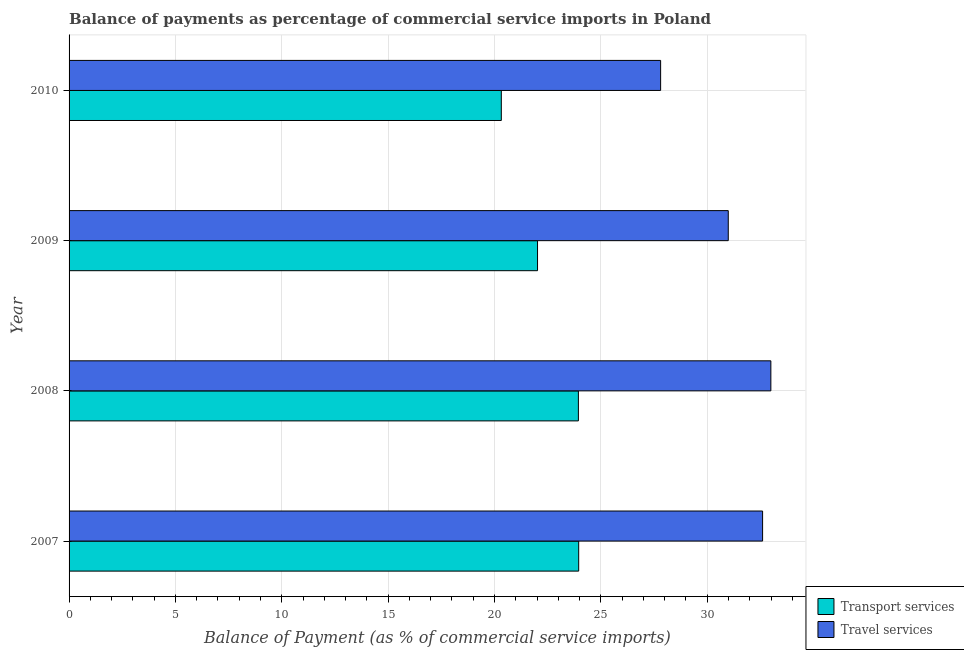How many groups of bars are there?
Your answer should be very brief. 4. Are the number of bars per tick equal to the number of legend labels?
Give a very brief answer. Yes. How many bars are there on the 4th tick from the bottom?
Your answer should be very brief. 2. In how many cases, is the number of bars for a given year not equal to the number of legend labels?
Provide a succinct answer. 0. What is the balance of payments of travel services in 2008?
Provide a succinct answer. 32.99. Across all years, what is the maximum balance of payments of transport services?
Offer a terse response. 23.96. Across all years, what is the minimum balance of payments of transport services?
Your response must be concise. 20.32. In which year was the balance of payments of travel services maximum?
Provide a short and direct response. 2008. What is the total balance of payments of transport services in the graph?
Your response must be concise. 90.24. What is the difference between the balance of payments of travel services in 2009 and that in 2010?
Offer a very short reply. 3.18. What is the difference between the balance of payments of transport services in 2009 and the balance of payments of travel services in 2007?
Ensure brevity in your answer.  -10.58. What is the average balance of payments of transport services per year?
Offer a very short reply. 22.56. In the year 2010, what is the difference between the balance of payments of travel services and balance of payments of transport services?
Your answer should be compact. 7.49. What is the ratio of the balance of payments of travel services in 2008 to that in 2009?
Your answer should be compact. 1.06. Is the difference between the balance of payments of transport services in 2007 and 2008 greater than the difference between the balance of payments of travel services in 2007 and 2008?
Your response must be concise. Yes. What is the difference between the highest and the second highest balance of payments of travel services?
Offer a very short reply. 0.39. What is the difference between the highest and the lowest balance of payments of travel services?
Your answer should be compact. 5.18. Is the sum of the balance of payments of travel services in 2008 and 2010 greater than the maximum balance of payments of transport services across all years?
Your answer should be very brief. Yes. What does the 1st bar from the top in 2008 represents?
Make the answer very short. Travel services. What does the 2nd bar from the bottom in 2009 represents?
Your answer should be very brief. Travel services. Does the graph contain grids?
Make the answer very short. Yes. Where does the legend appear in the graph?
Offer a very short reply. Bottom right. How are the legend labels stacked?
Your answer should be very brief. Vertical. What is the title of the graph?
Provide a succinct answer. Balance of payments as percentage of commercial service imports in Poland. What is the label or title of the X-axis?
Provide a succinct answer. Balance of Payment (as % of commercial service imports). What is the label or title of the Y-axis?
Provide a short and direct response. Year. What is the Balance of Payment (as % of commercial service imports) in Transport services in 2007?
Provide a short and direct response. 23.96. What is the Balance of Payment (as % of commercial service imports) in Travel services in 2007?
Offer a very short reply. 32.6. What is the Balance of Payment (as % of commercial service imports) of Transport services in 2008?
Your answer should be compact. 23.94. What is the Balance of Payment (as % of commercial service imports) of Travel services in 2008?
Keep it short and to the point. 32.99. What is the Balance of Payment (as % of commercial service imports) in Transport services in 2009?
Offer a terse response. 22.02. What is the Balance of Payment (as % of commercial service imports) of Travel services in 2009?
Give a very brief answer. 30.99. What is the Balance of Payment (as % of commercial service imports) of Transport services in 2010?
Your response must be concise. 20.32. What is the Balance of Payment (as % of commercial service imports) in Travel services in 2010?
Offer a terse response. 27.81. Across all years, what is the maximum Balance of Payment (as % of commercial service imports) in Transport services?
Give a very brief answer. 23.96. Across all years, what is the maximum Balance of Payment (as % of commercial service imports) in Travel services?
Provide a short and direct response. 32.99. Across all years, what is the minimum Balance of Payment (as % of commercial service imports) in Transport services?
Provide a succinct answer. 20.32. Across all years, what is the minimum Balance of Payment (as % of commercial service imports) of Travel services?
Your answer should be compact. 27.81. What is the total Balance of Payment (as % of commercial service imports) in Transport services in the graph?
Offer a terse response. 90.24. What is the total Balance of Payment (as % of commercial service imports) of Travel services in the graph?
Make the answer very short. 124.39. What is the difference between the Balance of Payment (as % of commercial service imports) in Transport services in 2007 and that in 2008?
Your answer should be very brief. 0.01. What is the difference between the Balance of Payment (as % of commercial service imports) of Travel services in 2007 and that in 2008?
Your answer should be very brief. -0.39. What is the difference between the Balance of Payment (as % of commercial service imports) of Transport services in 2007 and that in 2009?
Ensure brevity in your answer.  1.93. What is the difference between the Balance of Payment (as % of commercial service imports) in Travel services in 2007 and that in 2009?
Keep it short and to the point. 1.61. What is the difference between the Balance of Payment (as % of commercial service imports) of Transport services in 2007 and that in 2010?
Ensure brevity in your answer.  3.64. What is the difference between the Balance of Payment (as % of commercial service imports) of Travel services in 2007 and that in 2010?
Your answer should be very brief. 4.79. What is the difference between the Balance of Payment (as % of commercial service imports) in Transport services in 2008 and that in 2009?
Give a very brief answer. 1.92. What is the difference between the Balance of Payment (as % of commercial service imports) in Travel services in 2008 and that in 2009?
Offer a terse response. 2. What is the difference between the Balance of Payment (as % of commercial service imports) of Transport services in 2008 and that in 2010?
Your answer should be compact. 3.62. What is the difference between the Balance of Payment (as % of commercial service imports) in Travel services in 2008 and that in 2010?
Your response must be concise. 5.18. What is the difference between the Balance of Payment (as % of commercial service imports) of Transport services in 2009 and that in 2010?
Offer a terse response. 1.7. What is the difference between the Balance of Payment (as % of commercial service imports) in Travel services in 2009 and that in 2010?
Give a very brief answer. 3.18. What is the difference between the Balance of Payment (as % of commercial service imports) in Transport services in 2007 and the Balance of Payment (as % of commercial service imports) in Travel services in 2008?
Offer a terse response. -9.03. What is the difference between the Balance of Payment (as % of commercial service imports) of Transport services in 2007 and the Balance of Payment (as % of commercial service imports) of Travel services in 2009?
Offer a very short reply. -7.03. What is the difference between the Balance of Payment (as % of commercial service imports) of Transport services in 2007 and the Balance of Payment (as % of commercial service imports) of Travel services in 2010?
Give a very brief answer. -3.85. What is the difference between the Balance of Payment (as % of commercial service imports) of Transport services in 2008 and the Balance of Payment (as % of commercial service imports) of Travel services in 2009?
Offer a very short reply. -7.05. What is the difference between the Balance of Payment (as % of commercial service imports) in Transport services in 2008 and the Balance of Payment (as % of commercial service imports) in Travel services in 2010?
Keep it short and to the point. -3.87. What is the difference between the Balance of Payment (as % of commercial service imports) of Transport services in 2009 and the Balance of Payment (as % of commercial service imports) of Travel services in 2010?
Offer a very short reply. -5.79. What is the average Balance of Payment (as % of commercial service imports) in Transport services per year?
Make the answer very short. 22.56. What is the average Balance of Payment (as % of commercial service imports) of Travel services per year?
Provide a succinct answer. 31.1. In the year 2007, what is the difference between the Balance of Payment (as % of commercial service imports) of Transport services and Balance of Payment (as % of commercial service imports) of Travel services?
Provide a succinct answer. -8.65. In the year 2008, what is the difference between the Balance of Payment (as % of commercial service imports) of Transport services and Balance of Payment (as % of commercial service imports) of Travel services?
Give a very brief answer. -9.05. In the year 2009, what is the difference between the Balance of Payment (as % of commercial service imports) in Transport services and Balance of Payment (as % of commercial service imports) in Travel services?
Your response must be concise. -8.97. In the year 2010, what is the difference between the Balance of Payment (as % of commercial service imports) of Transport services and Balance of Payment (as % of commercial service imports) of Travel services?
Your answer should be compact. -7.49. What is the ratio of the Balance of Payment (as % of commercial service imports) of Transport services in 2007 to that in 2009?
Keep it short and to the point. 1.09. What is the ratio of the Balance of Payment (as % of commercial service imports) of Travel services in 2007 to that in 2009?
Ensure brevity in your answer.  1.05. What is the ratio of the Balance of Payment (as % of commercial service imports) in Transport services in 2007 to that in 2010?
Your response must be concise. 1.18. What is the ratio of the Balance of Payment (as % of commercial service imports) of Travel services in 2007 to that in 2010?
Your response must be concise. 1.17. What is the ratio of the Balance of Payment (as % of commercial service imports) of Transport services in 2008 to that in 2009?
Offer a terse response. 1.09. What is the ratio of the Balance of Payment (as % of commercial service imports) of Travel services in 2008 to that in 2009?
Your answer should be very brief. 1.06. What is the ratio of the Balance of Payment (as % of commercial service imports) in Transport services in 2008 to that in 2010?
Offer a terse response. 1.18. What is the ratio of the Balance of Payment (as % of commercial service imports) of Travel services in 2008 to that in 2010?
Your answer should be compact. 1.19. What is the ratio of the Balance of Payment (as % of commercial service imports) of Transport services in 2009 to that in 2010?
Offer a terse response. 1.08. What is the ratio of the Balance of Payment (as % of commercial service imports) of Travel services in 2009 to that in 2010?
Provide a succinct answer. 1.11. What is the difference between the highest and the second highest Balance of Payment (as % of commercial service imports) in Transport services?
Offer a terse response. 0.01. What is the difference between the highest and the second highest Balance of Payment (as % of commercial service imports) of Travel services?
Provide a short and direct response. 0.39. What is the difference between the highest and the lowest Balance of Payment (as % of commercial service imports) in Transport services?
Keep it short and to the point. 3.64. What is the difference between the highest and the lowest Balance of Payment (as % of commercial service imports) of Travel services?
Your answer should be compact. 5.18. 